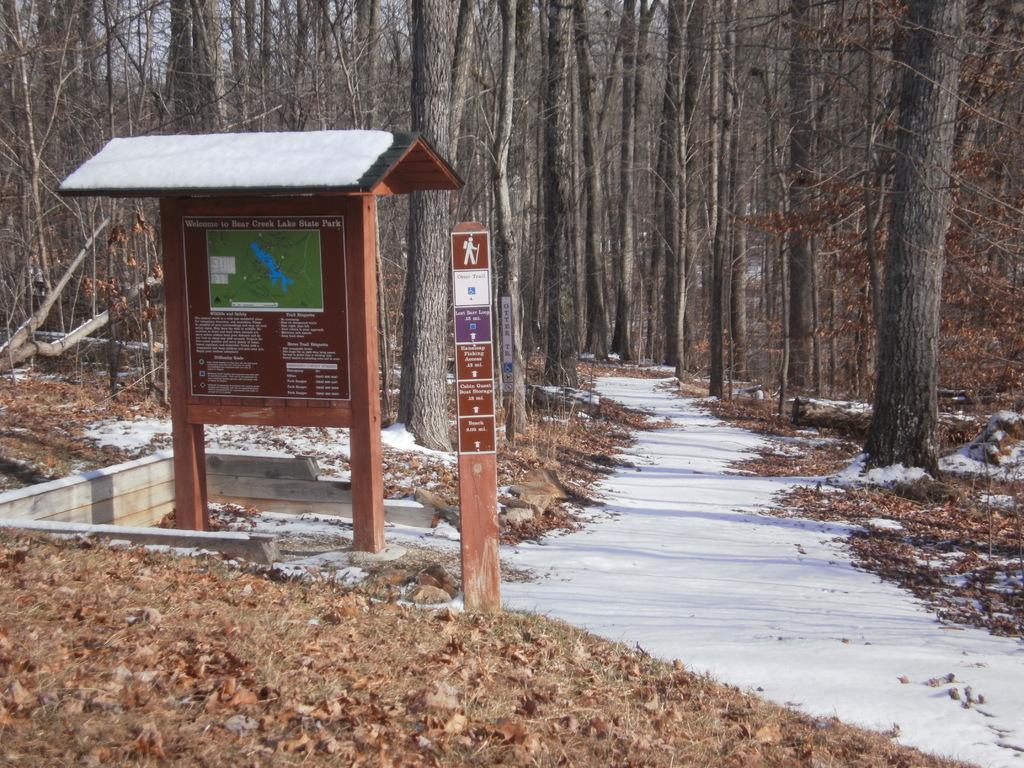How would you summarize this image in a sentence or two? On the left side of the image we can see boards, roof. In the background of the image we can see the trees. At the bottom of the image we can see the dry leaves, dry grass and snow. In the top left corner we can see the sky. 